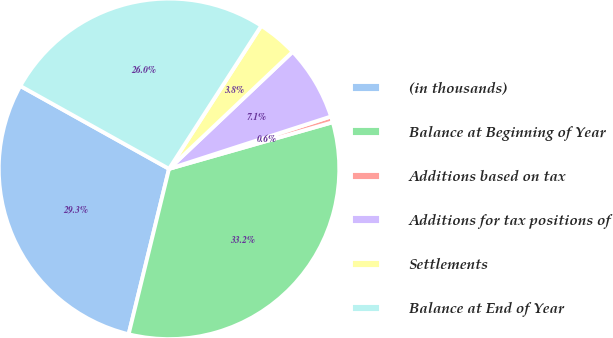Convert chart to OTSL. <chart><loc_0><loc_0><loc_500><loc_500><pie_chart><fcel>(in thousands)<fcel>Balance at Beginning of Year<fcel>Additions based on tax<fcel>Additions for tax positions of<fcel>Settlements<fcel>Balance at End of Year<nl><fcel>29.28%<fcel>33.23%<fcel>0.56%<fcel>7.09%<fcel>3.82%<fcel>26.02%<nl></chart> 